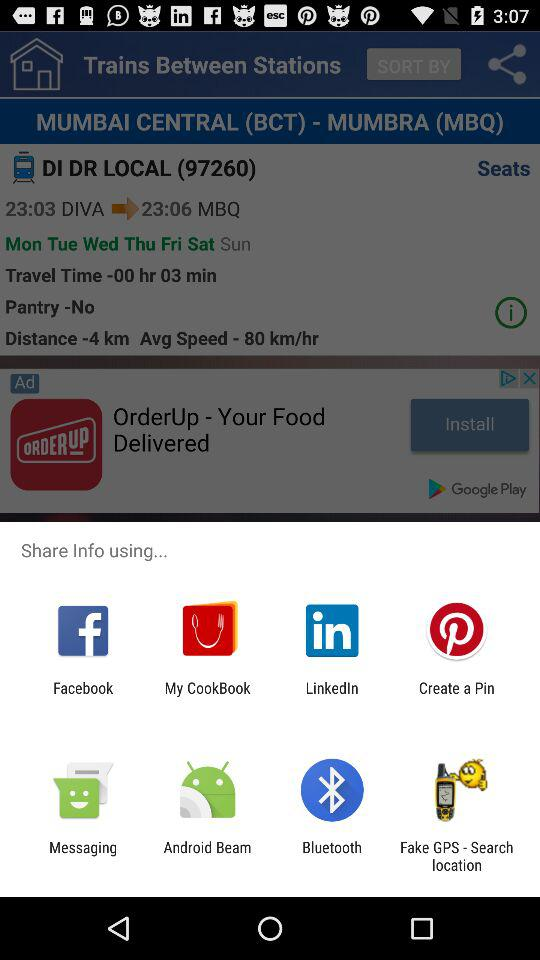On which days does the train run between "MUMBAI CENTRAL" and "MUMBRA"? The train runs between "MUMBAI CENTRAL" and "MUMBRA" on Monday, Tuesday, Wednesday, Thursday, Friday and Saturday. 